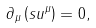<formula> <loc_0><loc_0><loc_500><loc_500>\partial _ { \mu } \left ( s u ^ { \mu } \right ) = 0 ,</formula> 